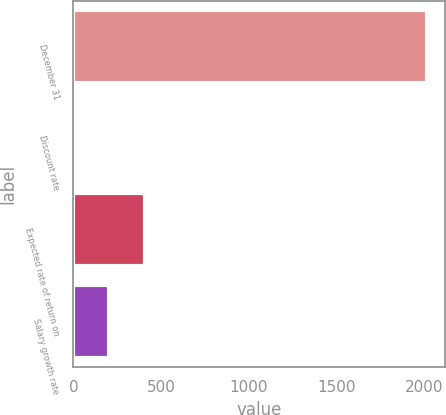<chart> <loc_0><loc_0><loc_500><loc_500><bar_chart><fcel>December 31<fcel>Discount rate<fcel>Expected rate of return on<fcel>Salary growth rate<nl><fcel>2015<fcel>4.2<fcel>406.36<fcel>205.28<nl></chart> 